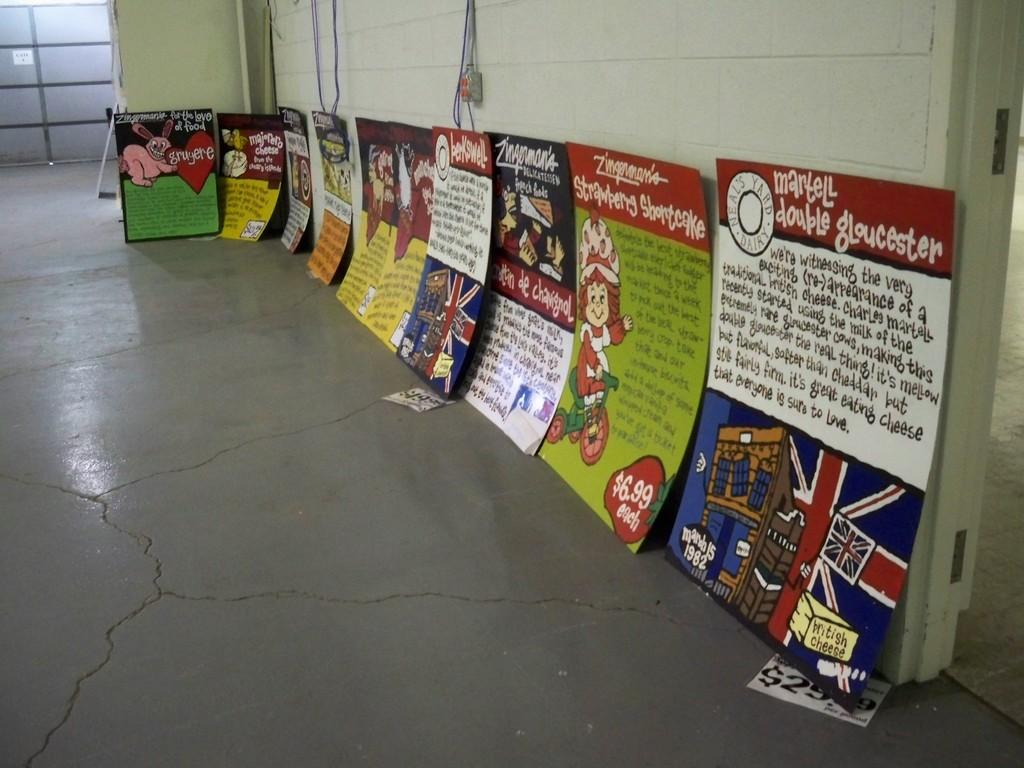<image>
Offer a succinct explanation of the picture presented. a poster with the word gloucester at the top 